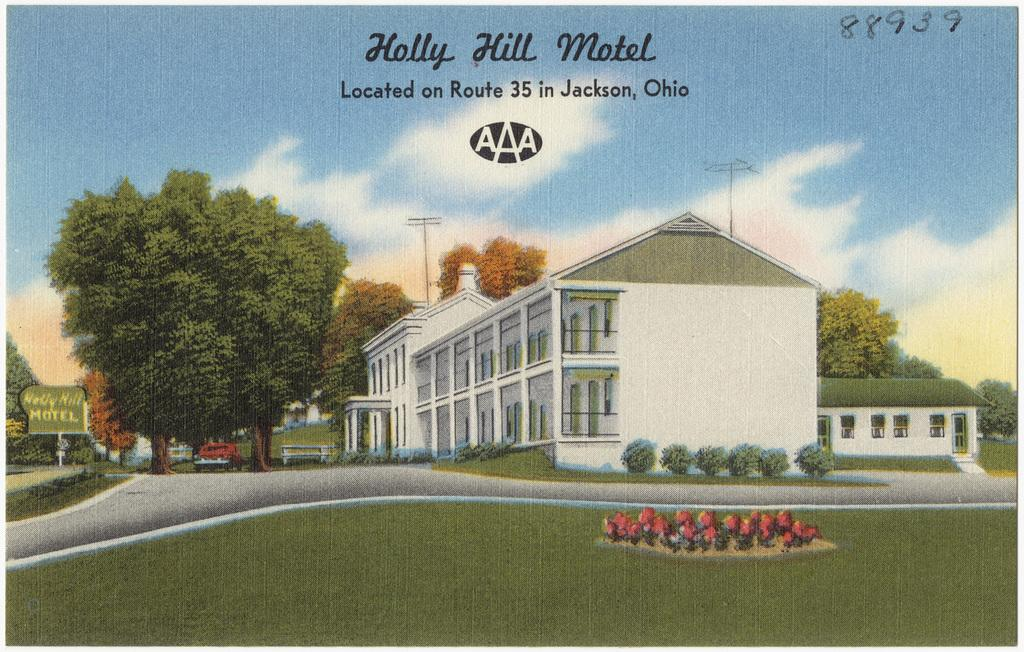What type of structures can be seen in the image? There are houses in the image. What natural elements are present in the image? There are trees, flowers, plants, grass, and clouds in the sky in the image. What man-made objects can be seen in the image? There are poles, pillars, windows, a board, and a vehicle in the image. How is the sky depicted in the image? The sky is visible in the background of the image, with clouds present. What title: What is the title of the book that is being read by the person in the image? There is no person or book present in the image. thing: What type of thing is being used to catch the fish in the image? There is no fishing activity or equipment present in the image. 